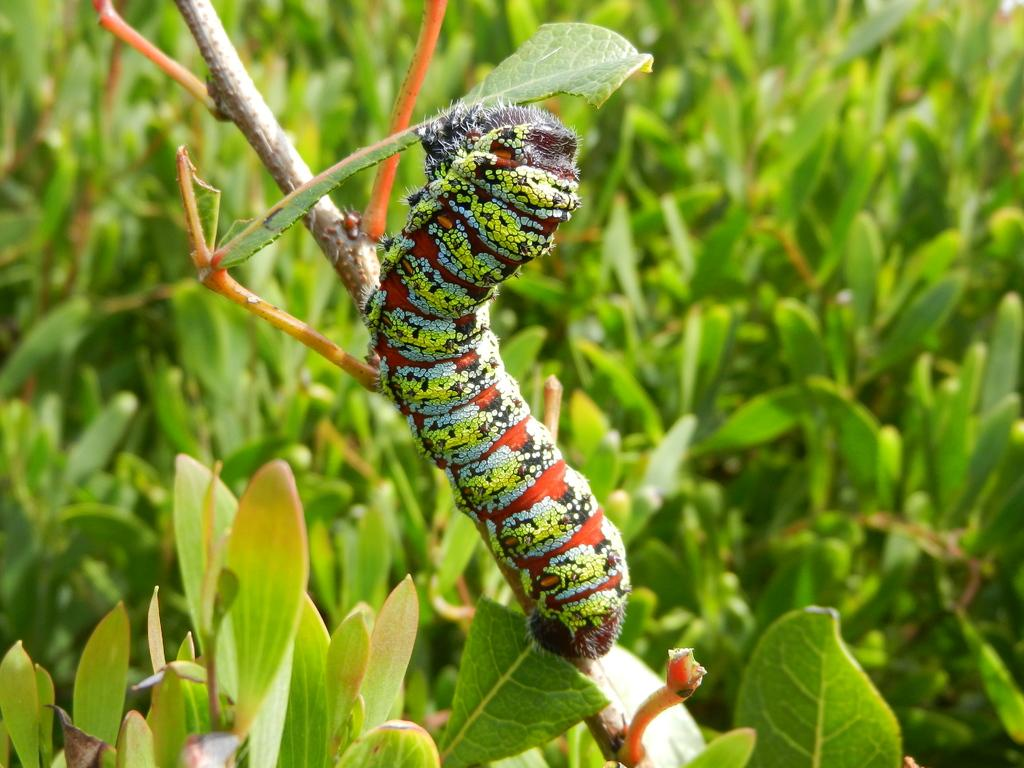What is located on the stem of the plant in the image? There is a caterpillar on the stem of a plant in the image. What type of vegetation can be seen in the image? There are green leaves visible in the image. What crime is the caterpillar committing in the image? There is no crime being committed in the image; it simply shows a caterpillar on a plant stem. How many eyes can be seen on the caterpillar in the image? Caterpillars do not have eyes like humans or other animals, so it is not possible to count eyes on the caterpillar in the image. 